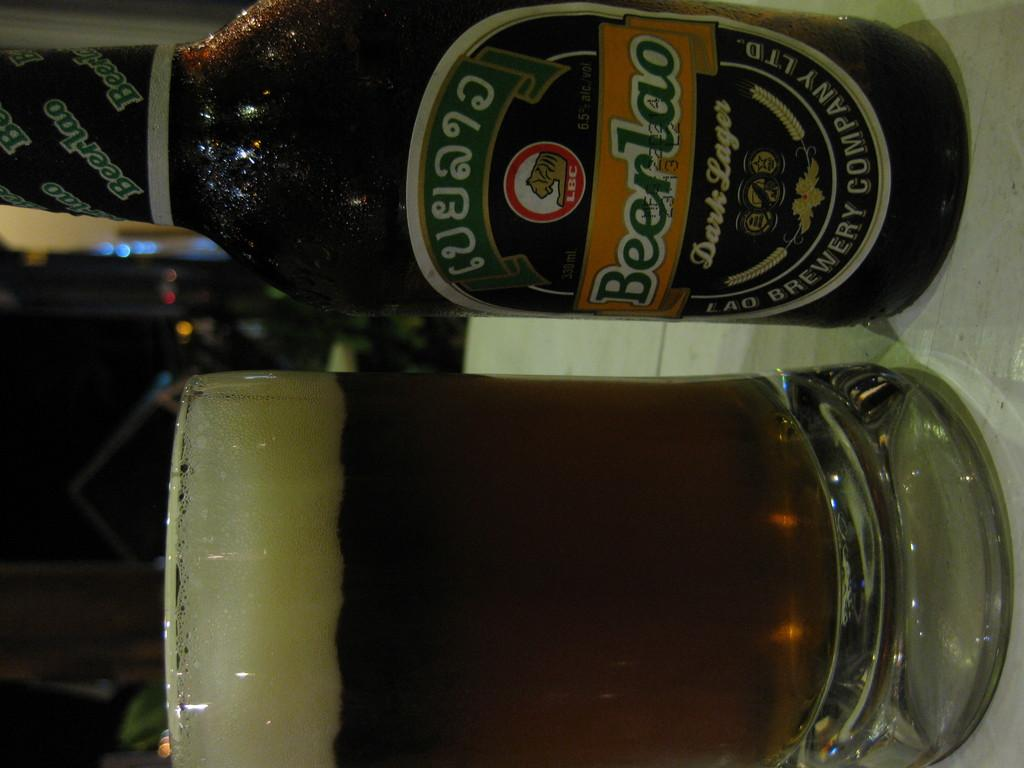<image>
Relay a brief, clear account of the picture shown. a glass and bottle of Beerlao Dark Lager on a table 